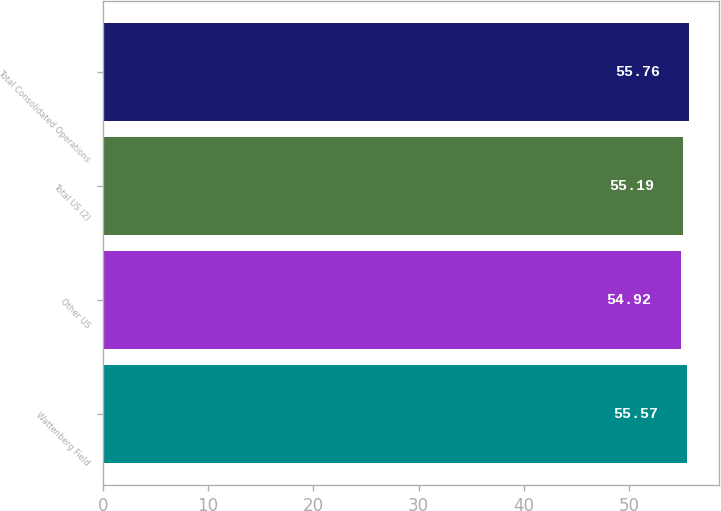<chart> <loc_0><loc_0><loc_500><loc_500><bar_chart><fcel>Wattenberg Field<fcel>Other US<fcel>Total US (2)<fcel>Total Consolidated Operations<nl><fcel>55.57<fcel>54.92<fcel>55.19<fcel>55.76<nl></chart> 